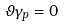<formula> <loc_0><loc_0><loc_500><loc_500>\vartheta \gamma _ { p } = 0</formula> 